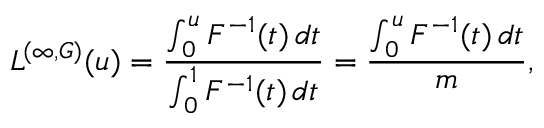<formula> <loc_0><loc_0><loc_500><loc_500>L ^ { ( \infty , G ) } ( u ) = \frac { \int _ { 0 } ^ { u } { F ^ { - 1 } ( t ) \, d t } } { \int _ { 0 } ^ { 1 } { F ^ { - 1 } ( t ) \, d t } } = \frac { \int _ { 0 } ^ { u } { F ^ { - 1 } ( t ) \, d t } } { m } ,</formula> 